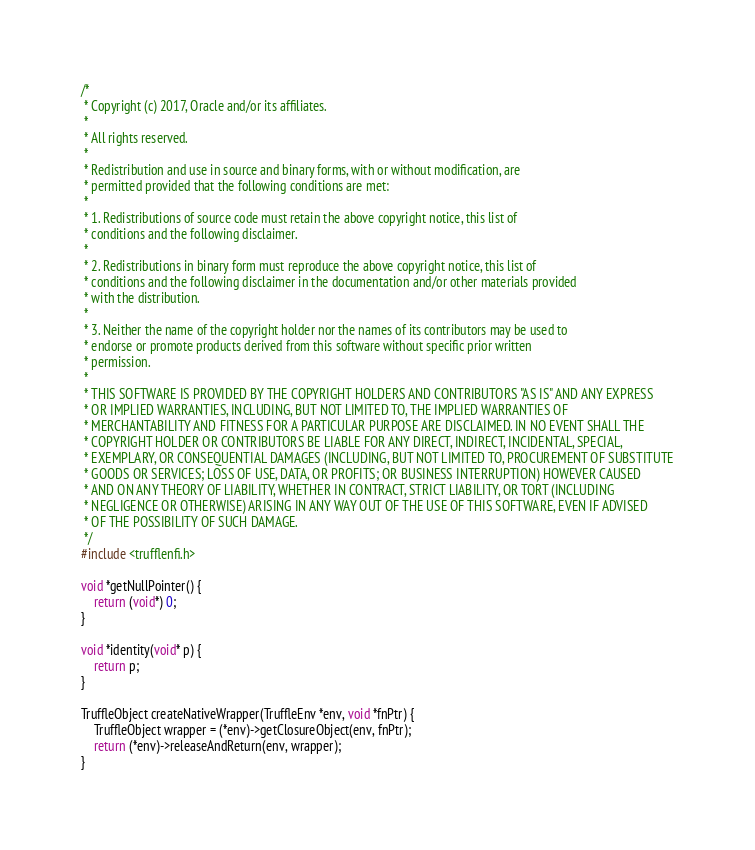<code> <loc_0><loc_0><loc_500><loc_500><_C_>/*
 * Copyright (c) 2017, Oracle and/or its affiliates.
 *
 * All rights reserved.
 *
 * Redistribution and use in source and binary forms, with or without modification, are
 * permitted provided that the following conditions are met:
 *
 * 1. Redistributions of source code must retain the above copyright notice, this list of
 * conditions and the following disclaimer.
 *
 * 2. Redistributions in binary form must reproduce the above copyright notice, this list of
 * conditions and the following disclaimer in the documentation and/or other materials provided
 * with the distribution.
 *
 * 3. Neither the name of the copyright holder nor the names of its contributors may be used to
 * endorse or promote products derived from this software without specific prior written
 * permission.
 *
 * THIS SOFTWARE IS PROVIDED BY THE COPYRIGHT HOLDERS AND CONTRIBUTORS "AS IS" AND ANY EXPRESS
 * OR IMPLIED WARRANTIES, INCLUDING, BUT NOT LIMITED TO, THE IMPLIED WARRANTIES OF
 * MERCHANTABILITY AND FITNESS FOR A PARTICULAR PURPOSE ARE DISCLAIMED. IN NO EVENT SHALL THE
 * COPYRIGHT HOLDER OR CONTRIBUTORS BE LIABLE FOR ANY DIRECT, INDIRECT, INCIDENTAL, SPECIAL,
 * EXEMPLARY, OR CONSEQUENTIAL DAMAGES (INCLUDING, BUT NOT LIMITED TO, PROCUREMENT OF SUBSTITUTE
 * GOODS OR SERVICES; LOSS OF USE, DATA, OR PROFITS; OR BUSINESS INTERRUPTION) HOWEVER CAUSED
 * AND ON ANY THEORY OF LIABILITY, WHETHER IN CONTRACT, STRICT LIABILITY, OR TORT (INCLUDING
 * NEGLIGENCE OR OTHERWISE) ARISING IN ANY WAY OUT OF THE USE OF THIS SOFTWARE, EVEN IF ADVISED
 * OF THE POSSIBILITY OF SUCH DAMAGE.
 */
#include <trufflenfi.h>

void *getNullPointer() {
    return (void*) 0;
}

void *identity(void* p) {
    return p;
}

TruffleObject createNativeWrapper(TruffleEnv *env, void *fnPtr) {
    TruffleObject wrapper = (*env)->getClosureObject(env, fnPtr);
    return (*env)->releaseAndReturn(env, wrapper);
}
</code> 